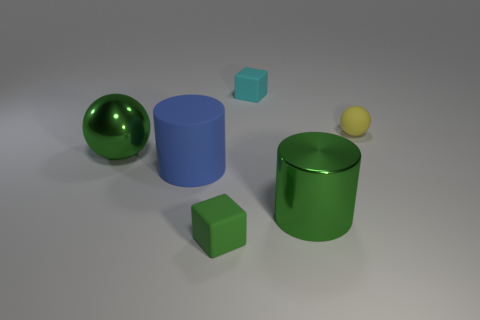Add 4 tiny gray blocks. How many objects exist? 10 Subtract all blocks. How many objects are left? 4 Subtract all tiny rubber things. Subtract all yellow matte objects. How many objects are left? 2 Add 1 green shiny balls. How many green shiny balls are left? 2 Add 2 large red shiny cylinders. How many large red shiny cylinders exist? 2 Subtract 1 green spheres. How many objects are left? 5 